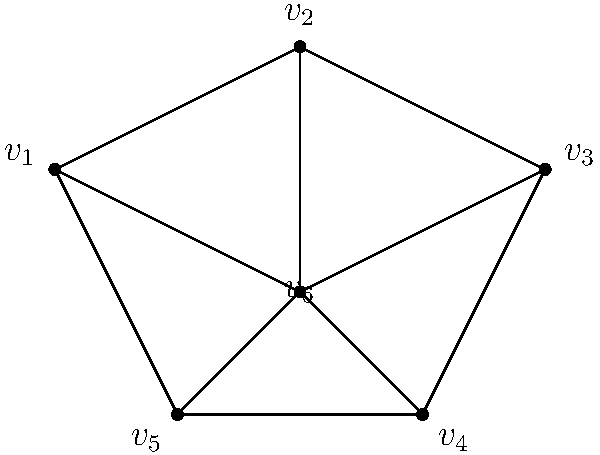In the social network graph above representing employees in a company, which vertex has the highest degree centrality and is therefore likely to be the most influential in promoting a new wellness program? To determine the vertex with the highest degree centrality, we need to count the number of edges connected to each vertex:

1. Count the degree (number of connections) for each vertex:
   $v_1$: 3 connections
   $v_2$: 3 connections
   $v_3$: 3 connections
   $v_4$: 3 connections
   $v_5$: 3 connections
   $v_6$: 5 connections

2. Identify the vertex with the highest degree:
   $v_6$ has the highest degree with 5 connections.

3. Interpret the result:
   The vertex with the highest degree centrality is most likely to be influential in the network, as it has the most direct connections to other nodes. In the context of promoting a wellness program, this employee would have the greatest reach and potential influence over others.

Therefore, vertex $v_6$ has the highest degree centrality and is likely to be the most influential in promoting the new wellness program.
Answer: $v_6$ 